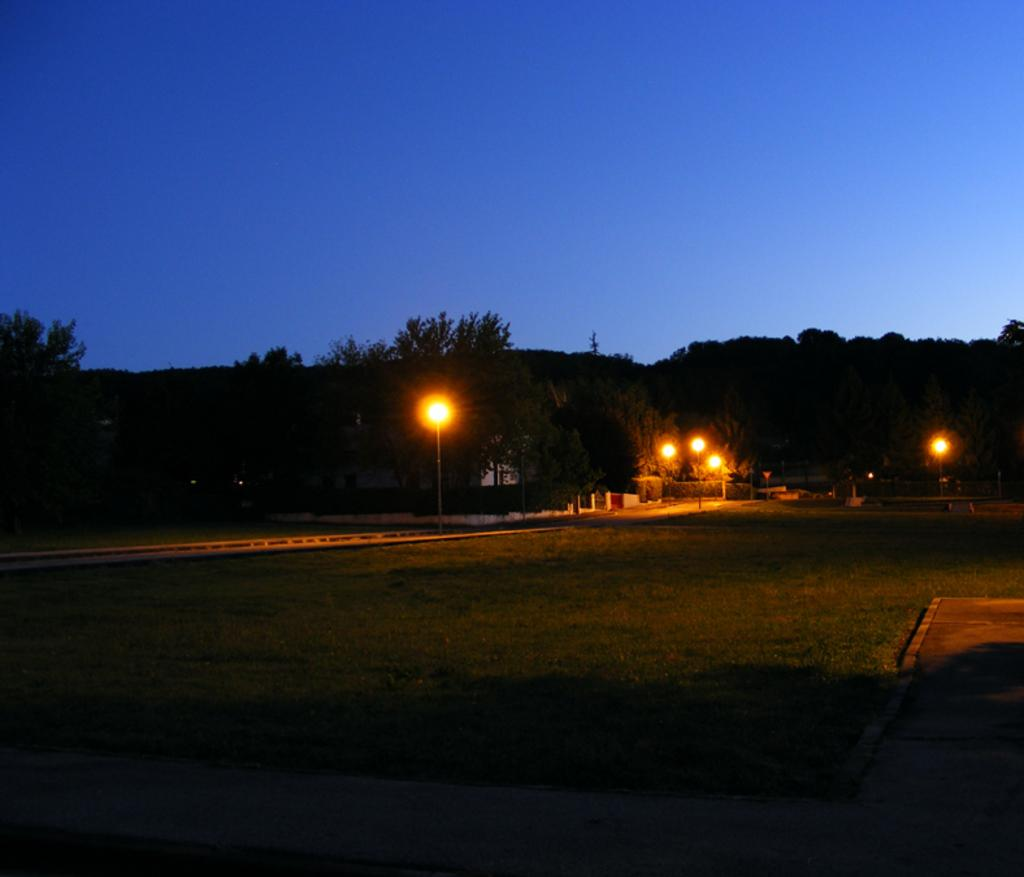What is located in the center of the image? There are trees, grass, lights, and a road in the center of the image. What type of vegetation can be seen in the image? There are trees and grass in the image. What is the condition of the sky in the image? The sky is visible in the image. What property does the month of June have in the image? There is no mention of a specific month or any property related to a month in the image. 